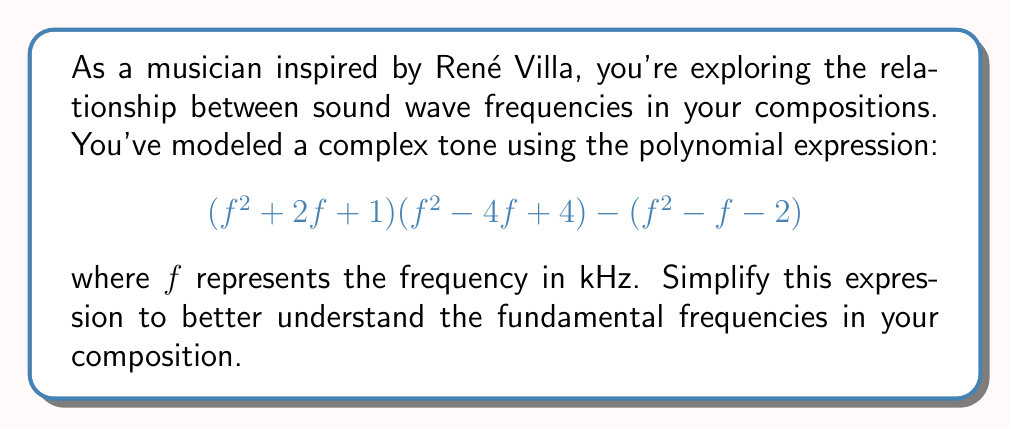Could you help me with this problem? Let's approach this step-by-step:

1) First, let's expand $(f^2 + 2f + 1)(f^2 - 4f + 4)$:
   $$(f^2 + 2f + 1)(f^2 - 4f + 4) = f^4 - 4f^3 + 4f^2 + 2f^3 - 8f^2 + 8f + f^2 - 4f + 4$$
   $$= f^4 - 2f^3 - 3f^2 + 4f + 4$$

2) Now our expression looks like:
   $$(f^4 - 2f^3 - 3f^2 + 4f + 4) - (f^2 - f - 2)$$

3) Let's subtract the second part from the first:
   $$f^4 - 2f^3 - 3f^2 + 4f + 4 - (f^2 - f - 2)$$
   $$= f^4 - 2f^3 - 3f^2 + 4f + 4 - f^2 + f + 2$$
   $$= f^4 - 2f^3 - 4f^2 + 5f + 6$$

4) This is our simplified polynomial. We can factor it further:
   $$f^4 - 2f^3 - 4f^2 + 5f + 6 = (f^2 - 3f - 2)(f^2 + f - 3)$$

5) We can factor these quadratic terms further:
   $$(f - 3)(f + 1)(f - 1)(f + 3)$$

This final factored form represents the fundamental frequencies in your composition.
Answer: $$(f - 3)(f + 1)(f - 1)(f + 3)$$ 